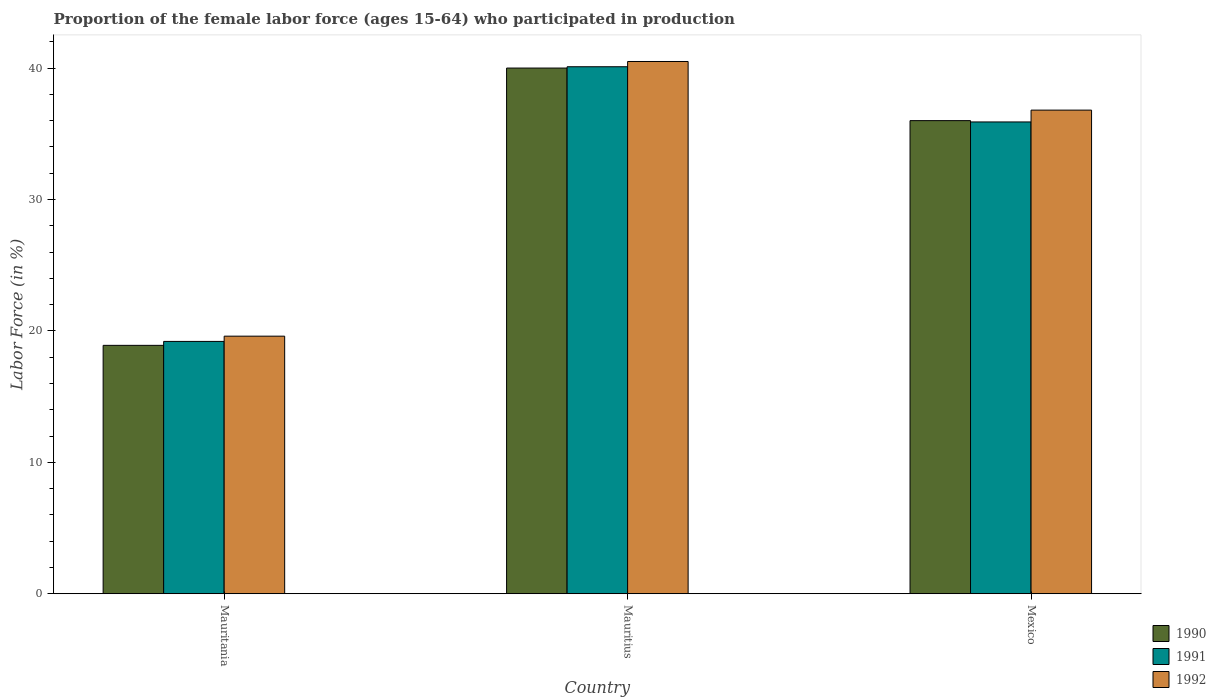How many different coloured bars are there?
Make the answer very short. 3. Are the number of bars per tick equal to the number of legend labels?
Keep it short and to the point. Yes. How many bars are there on the 1st tick from the left?
Your response must be concise. 3. What is the label of the 1st group of bars from the left?
Keep it short and to the point. Mauritania. What is the proportion of the female labor force who participated in production in 1990 in Mauritania?
Give a very brief answer. 18.9. Across all countries, what is the minimum proportion of the female labor force who participated in production in 1990?
Your answer should be compact. 18.9. In which country was the proportion of the female labor force who participated in production in 1992 maximum?
Give a very brief answer. Mauritius. In which country was the proportion of the female labor force who participated in production in 1992 minimum?
Give a very brief answer. Mauritania. What is the total proportion of the female labor force who participated in production in 1991 in the graph?
Give a very brief answer. 95.2. What is the difference between the proportion of the female labor force who participated in production in 1990 in Mauritania and that in Mauritius?
Keep it short and to the point. -21.1. What is the difference between the proportion of the female labor force who participated in production in 1990 in Mauritania and the proportion of the female labor force who participated in production in 1991 in Mauritius?
Make the answer very short. -21.2. What is the average proportion of the female labor force who participated in production in 1992 per country?
Make the answer very short. 32.3. What is the difference between the proportion of the female labor force who participated in production of/in 1992 and proportion of the female labor force who participated in production of/in 1991 in Mauritania?
Give a very brief answer. 0.4. What is the ratio of the proportion of the female labor force who participated in production in 1991 in Mauritius to that in Mexico?
Provide a short and direct response. 1.12. Is the proportion of the female labor force who participated in production in 1991 in Mauritania less than that in Mauritius?
Your answer should be compact. Yes. What is the difference between the highest and the second highest proportion of the female labor force who participated in production in 1992?
Offer a terse response. 20.9. What is the difference between the highest and the lowest proportion of the female labor force who participated in production in 1990?
Keep it short and to the point. 21.1. What does the 1st bar from the right in Mexico represents?
Offer a very short reply. 1992. Is it the case that in every country, the sum of the proportion of the female labor force who participated in production in 1991 and proportion of the female labor force who participated in production in 1992 is greater than the proportion of the female labor force who participated in production in 1990?
Give a very brief answer. Yes. What is the difference between two consecutive major ticks on the Y-axis?
Make the answer very short. 10. Does the graph contain any zero values?
Provide a short and direct response. No. Does the graph contain grids?
Provide a succinct answer. No. How many legend labels are there?
Ensure brevity in your answer.  3. How are the legend labels stacked?
Make the answer very short. Vertical. What is the title of the graph?
Keep it short and to the point. Proportion of the female labor force (ages 15-64) who participated in production. What is the label or title of the X-axis?
Offer a very short reply. Country. What is the Labor Force (in %) of 1990 in Mauritania?
Your response must be concise. 18.9. What is the Labor Force (in %) in 1991 in Mauritania?
Keep it short and to the point. 19.2. What is the Labor Force (in %) in 1992 in Mauritania?
Your answer should be compact. 19.6. What is the Labor Force (in %) in 1990 in Mauritius?
Ensure brevity in your answer.  40. What is the Labor Force (in %) in 1991 in Mauritius?
Offer a very short reply. 40.1. What is the Labor Force (in %) of 1992 in Mauritius?
Keep it short and to the point. 40.5. What is the Labor Force (in %) of 1990 in Mexico?
Offer a terse response. 36. What is the Labor Force (in %) in 1991 in Mexico?
Offer a terse response. 35.9. What is the Labor Force (in %) of 1992 in Mexico?
Give a very brief answer. 36.8. Across all countries, what is the maximum Labor Force (in %) in 1991?
Provide a succinct answer. 40.1. Across all countries, what is the maximum Labor Force (in %) in 1992?
Give a very brief answer. 40.5. Across all countries, what is the minimum Labor Force (in %) in 1990?
Your response must be concise. 18.9. Across all countries, what is the minimum Labor Force (in %) of 1991?
Your answer should be compact. 19.2. Across all countries, what is the minimum Labor Force (in %) in 1992?
Provide a short and direct response. 19.6. What is the total Labor Force (in %) of 1990 in the graph?
Give a very brief answer. 94.9. What is the total Labor Force (in %) in 1991 in the graph?
Provide a short and direct response. 95.2. What is the total Labor Force (in %) in 1992 in the graph?
Keep it short and to the point. 96.9. What is the difference between the Labor Force (in %) of 1990 in Mauritania and that in Mauritius?
Your response must be concise. -21.1. What is the difference between the Labor Force (in %) in 1991 in Mauritania and that in Mauritius?
Offer a terse response. -20.9. What is the difference between the Labor Force (in %) in 1992 in Mauritania and that in Mauritius?
Your answer should be very brief. -20.9. What is the difference between the Labor Force (in %) in 1990 in Mauritania and that in Mexico?
Your answer should be compact. -17.1. What is the difference between the Labor Force (in %) of 1991 in Mauritania and that in Mexico?
Offer a very short reply. -16.7. What is the difference between the Labor Force (in %) in 1992 in Mauritania and that in Mexico?
Your response must be concise. -17.2. What is the difference between the Labor Force (in %) in 1990 in Mauritius and that in Mexico?
Provide a succinct answer. 4. What is the difference between the Labor Force (in %) of 1991 in Mauritius and that in Mexico?
Provide a succinct answer. 4.2. What is the difference between the Labor Force (in %) of 1990 in Mauritania and the Labor Force (in %) of 1991 in Mauritius?
Provide a succinct answer. -21.2. What is the difference between the Labor Force (in %) of 1990 in Mauritania and the Labor Force (in %) of 1992 in Mauritius?
Offer a very short reply. -21.6. What is the difference between the Labor Force (in %) in 1991 in Mauritania and the Labor Force (in %) in 1992 in Mauritius?
Make the answer very short. -21.3. What is the difference between the Labor Force (in %) in 1990 in Mauritania and the Labor Force (in %) in 1991 in Mexico?
Provide a short and direct response. -17. What is the difference between the Labor Force (in %) of 1990 in Mauritania and the Labor Force (in %) of 1992 in Mexico?
Ensure brevity in your answer.  -17.9. What is the difference between the Labor Force (in %) in 1991 in Mauritania and the Labor Force (in %) in 1992 in Mexico?
Ensure brevity in your answer.  -17.6. What is the difference between the Labor Force (in %) of 1991 in Mauritius and the Labor Force (in %) of 1992 in Mexico?
Your answer should be compact. 3.3. What is the average Labor Force (in %) of 1990 per country?
Offer a very short reply. 31.63. What is the average Labor Force (in %) in 1991 per country?
Offer a very short reply. 31.73. What is the average Labor Force (in %) of 1992 per country?
Make the answer very short. 32.3. What is the difference between the Labor Force (in %) in 1990 and Labor Force (in %) in 1992 in Mauritius?
Give a very brief answer. -0.5. What is the difference between the Labor Force (in %) of 1991 and Labor Force (in %) of 1992 in Mexico?
Provide a short and direct response. -0.9. What is the ratio of the Labor Force (in %) in 1990 in Mauritania to that in Mauritius?
Ensure brevity in your answer.  0.47. What is the ratio of the Labor Force (in %) of 1991 in Mauritania to that in Mauritius?
Keep it short and to the point. 0.48. What is the ratio of the Labor Force (in %) in 1992 in Mauritania to that in Mauritius?
Offer a very short reply. 0.48. What is the ratio of the Labor Force (in %) in 1990 in Mauritania to that in Mexico?
Your response must be concise. 0.53. What is the ratio of the Labor Force (in %) in 1991 in Mauritania to that in Mexico?
Your answer should be compact. 0.53. What is the ratio of the Labor Force (in %) of 1992 in Mauritania to that in Mexico?
Offer a very short reply. 0.53. What is the ratio of the Labor Force (in %) in 1990 in Mauritius to that in Mexico?
Keep it short and to the point. 1.11. What is the ratio of the Labor Force (in %) of 1991 in Mauritius to that in Mexico?
Provide a short and direct response. 1.12. What is the ratio of the Labor Force (in %) in 1992 in Mauritius to that in Mexico?
Give a very brief answer. 1.1. What is the difference between the highest and the second highest Labor Force (in %) in 1992?
Keep it short and to the point. 3.7. What is the difference between the highest and the lowest Labor Force (in %) in 1990?
Make the answer very short. 21.1. What is the difference between the highest and the lowest Labor Force (in %) in 1991?
Provide a succinct answer. 20.9. What is the difference between the highest and the lowest Labor Force (in %) of 1992?
Your response must be concise. 20.9. 